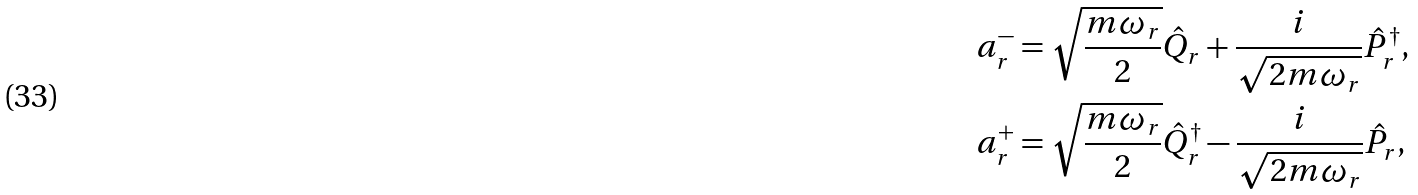<formula> <loc_0><loc_0><loc_500><loc_500>a _ { r } ^ { - } & = \sqrt { \frac { m \omega _ { r } } { 2 } } \hat { Q } _ { r } + \frac { i } { \sqrt { 2 m \omega _ { r } } } \hat { P } _ { r } ^ { \dagger } , \\ a _ { r } ^ { + } & = \sqrt { \frac { m \omega _ { r } } { 2 } } \hat { Q } _ { r } ^ { \dagger } - \frac { i } { \sqrt { 2 m \omega _ { r } } } \hat { P } _ { r } ,</formula> 